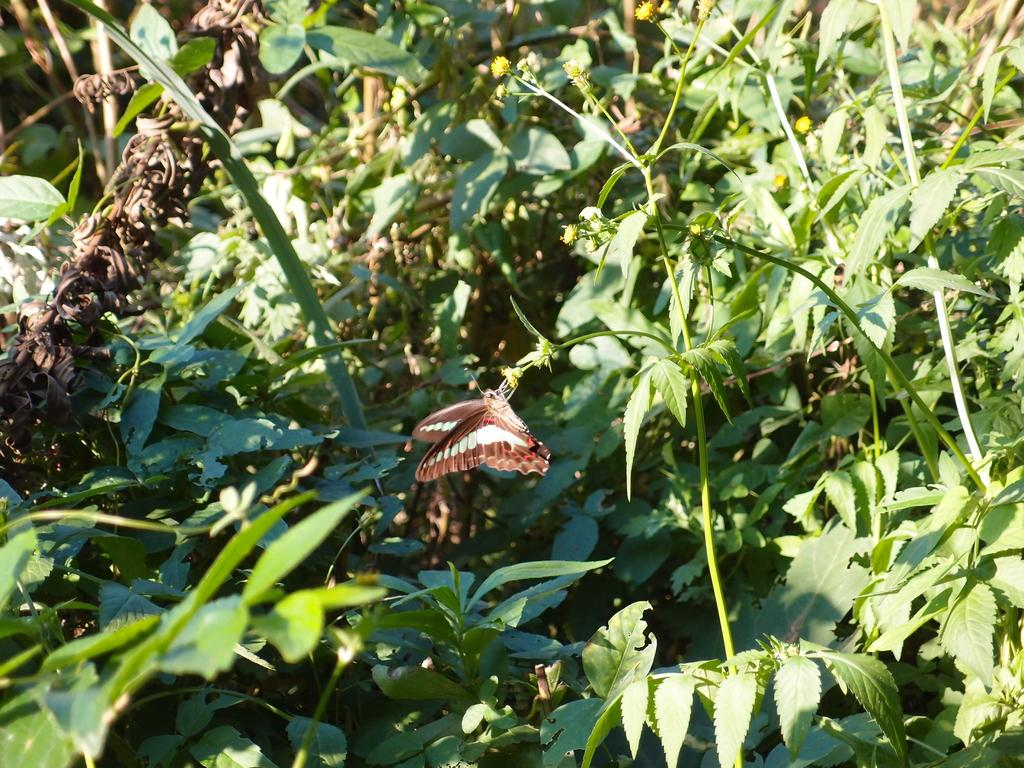What type of plants can be seen in the image? There are plants with flowers in the image. Is there any wildlife present in the image? Yes, there is a butterfly on a flower in the image. What is the current temperature in the image? The provided facts do not mention any information about the temperature, so it cannot be determined from the image. 